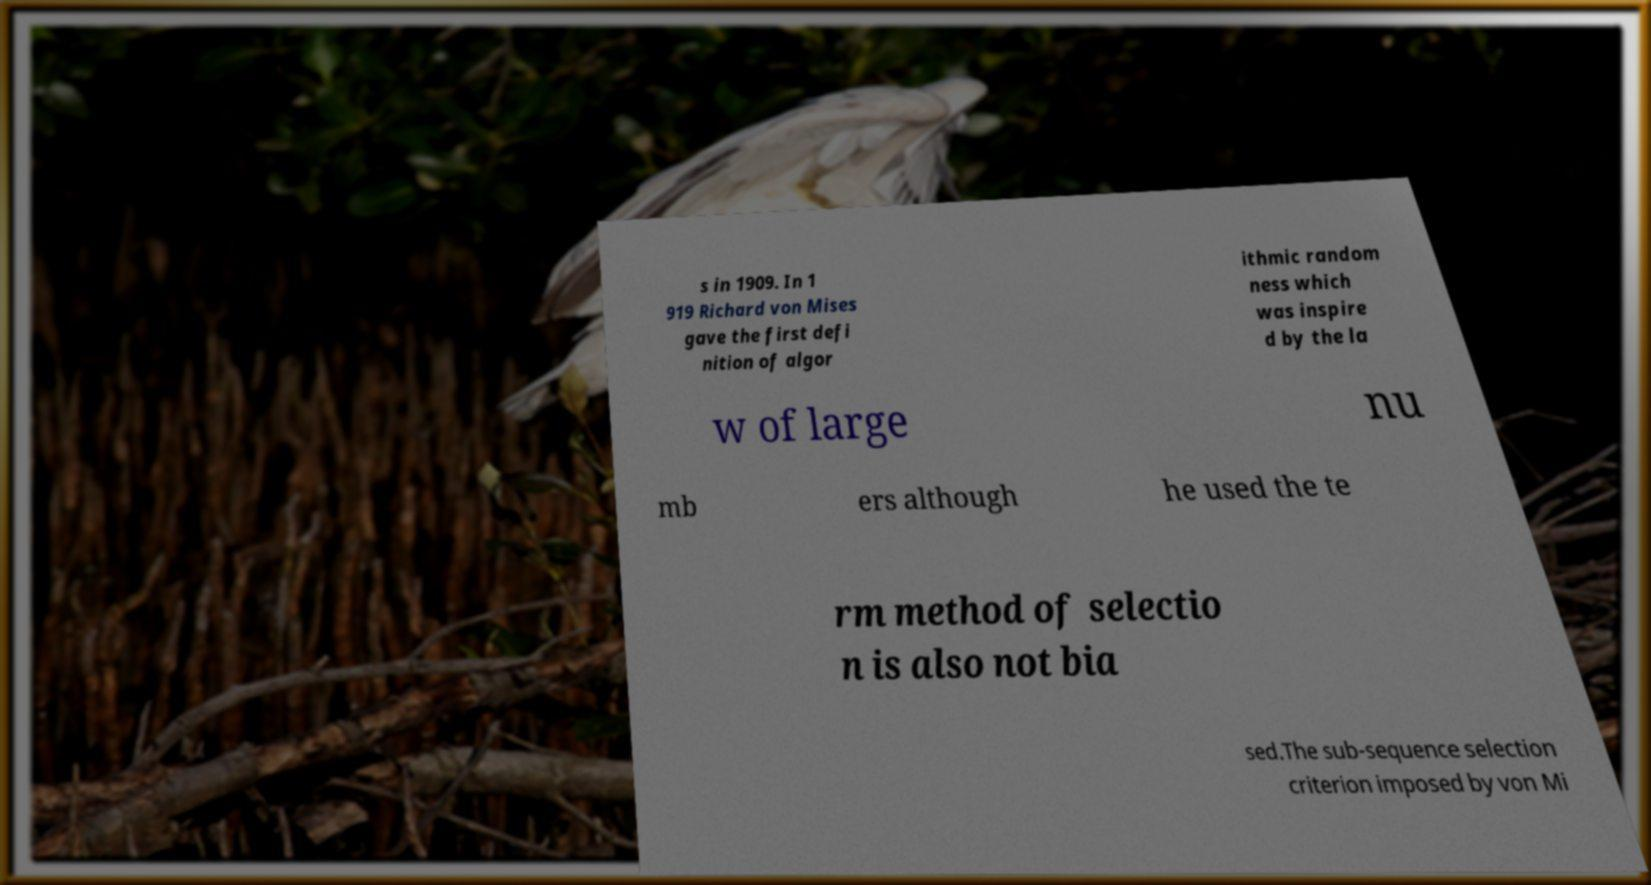I need the written content from this picture converted into text. Can you do that? s in 1909. In 1 919 Richard von Mises gave the first defi nition of algor ithmic random ness which was inspire d by the la w of large nu mb ers although he used the te rm method of selectio n is also not bia sed.The sub-sequence selection criterion imposed by von Mi 